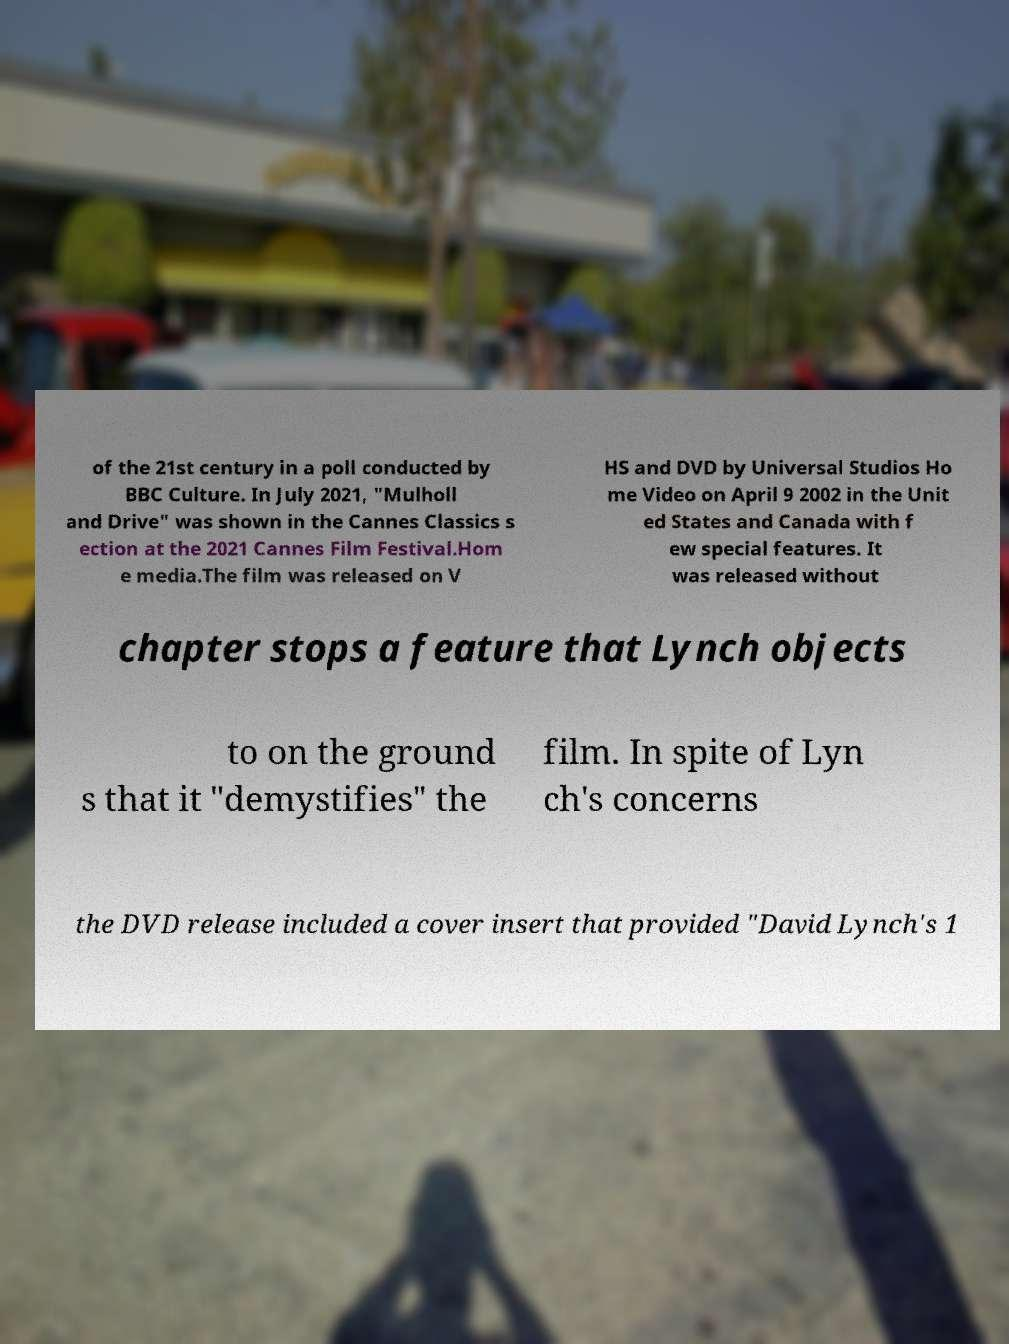I need the written content from this picture converted into text. Can you do that? of the 21st century in a poll conducted by BBC Culture. In July 2021, "Mulholl and Drive" was shown in the Cannes Classics s ection at the 2021 Cannes Film Festival.Hom e media.The film was released on V HS and DVD by Universal Studios Ho me Video on April 9 2002 in the Unit ed States and Canada with f ew special features. It was released without chapter stops a feature that Lynch objects to on the ground s that it "demystifies" the film. In spite of Lyn ch's concerns the DVD release included a cover insert that provided "David Lynch's 1 